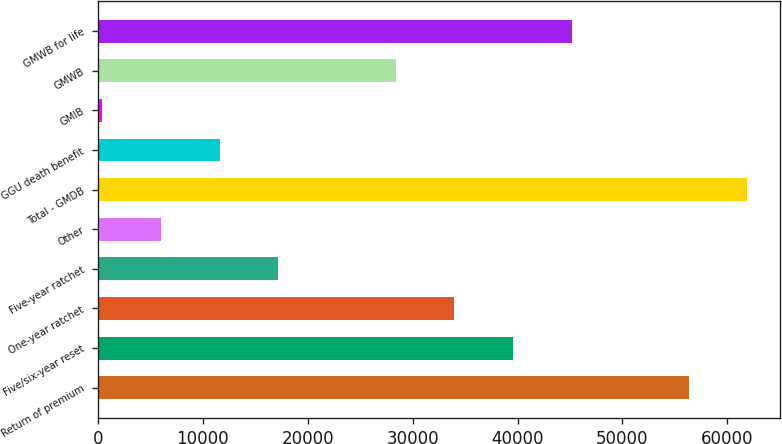<chart> <loc_0><loc_0><loc_500><loc_500><bar_chart><fcel>Return of premium<fcel>Five/six-year reset<fcel>One-year ratchet<fcel>Five-year ratchet<fcel>Other<fcel>Total - GMDB<fcel>GGU death benefit<fcel>GMIB<fcel>GMWB<fcel>GMWB for life<nl><fcel>56320<fcel>39553.9<fcel>33965.2<fcel>17199.1<fcel>6021.7<fcel>61908.7<fcel>11610.4<fcel>433<fcel>28376.5<fcel>45142.6<nl></chart> 